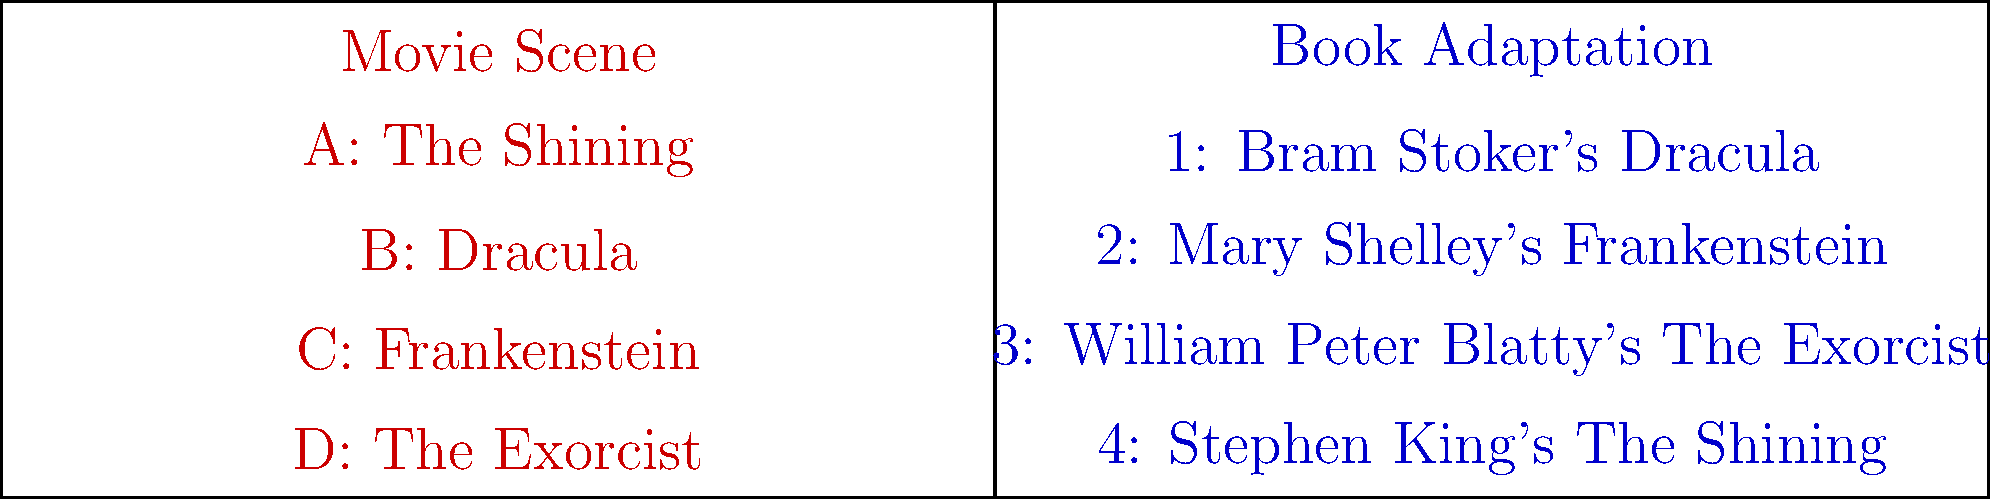Match the iconic horror movie scenes on the left with their corresponding book adaptations on the right. Which pairing represents the correct match between a classic horror film and its literary source? To answer this question, we need to match each movie scene with its corresponding book adaptation. Let's go through each pairing step-by-step:

1. A: The Shining
   This iconic horror film is based on Stephen King's novel of the same name.
   Correct match: 4: Stephen King's The Shining

2. B: Dracula
   The classic vampire movie is an adaptation of Bram Stoker's gothic horror novel.
   Correct match: 1: Bram Stoker's Dracula

3. C: Frankenstein
   This monster movie is based on Mary Shelley's groundbreaking science fiction horror novel.
   Correct match: 2: Mary Shelley's Frankenstein

4. D: The Exorcist
   This terrifying film about demonic possession is adapted from William Peter Blatty's novel.
   Correct match: 3: William Peter Blatty's The Exorcist

By matching each movie scene with its corresponding book adaptation, we can see that all pairings are correct. Each iconic horror film is accurately linked to its literary source.
Answer: All pairings are correct. 